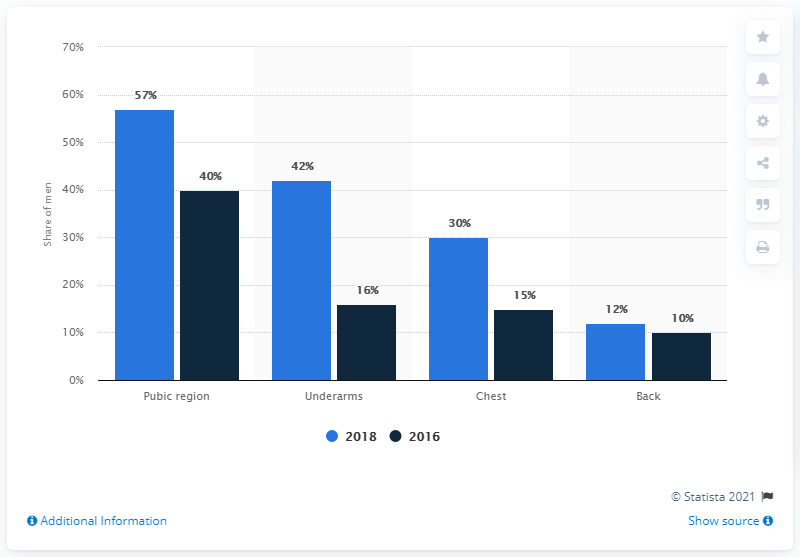Mention a couple of crucial points in this snapshot. In the year 2018, a significant number of young men began removing hair from their chest and back, a trend that has continued to the present day. According to data from 2016, a significant percentage of men shaved their underarms. 